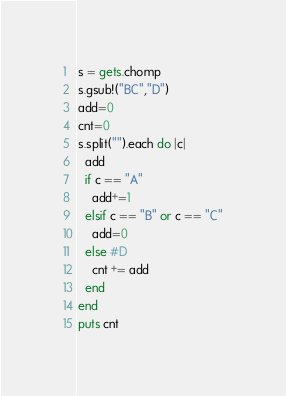<code> <loc_0><loc_0><loc_500><loc_500><_Ruby_>s = gets.chomp
s.gsub!("BC","D")
add=0
cnt=0
s.split("").each do |c|
  add
  if c == "A"
    add+=1
  elsif c == "B" or c == "C"
    add=0
  else #D
    cnt += add
  end
end
puts cnt</code> 